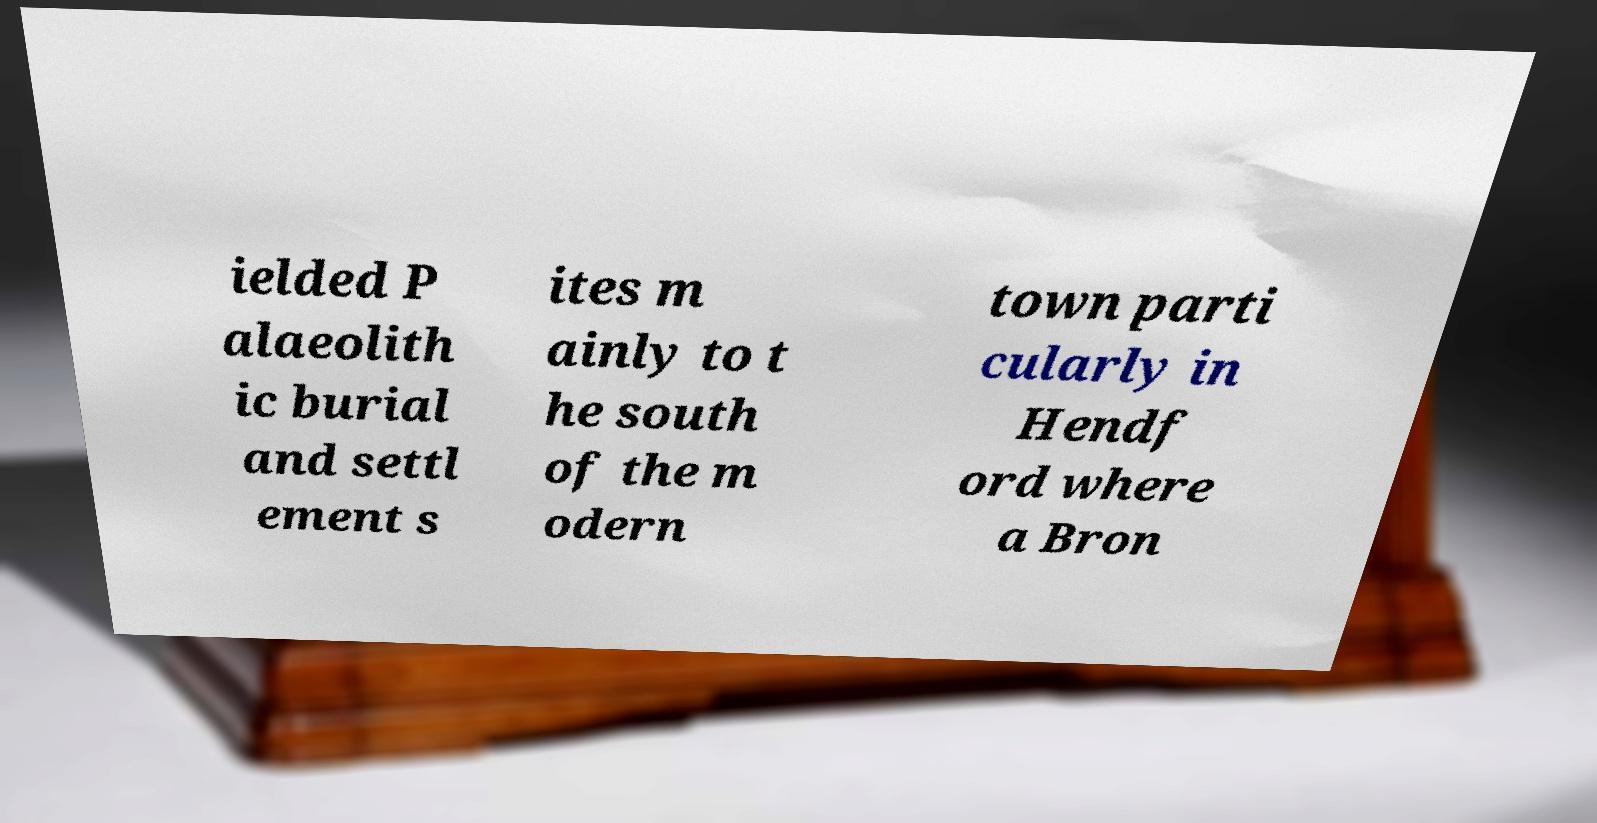Could you assist in decoding the text presented in this image and type it out clearly? ielded P alaeolith ic burial and settl ement s ites m ainly to t he south of the m odern town parti cularly in Hendf ord where a Bron 